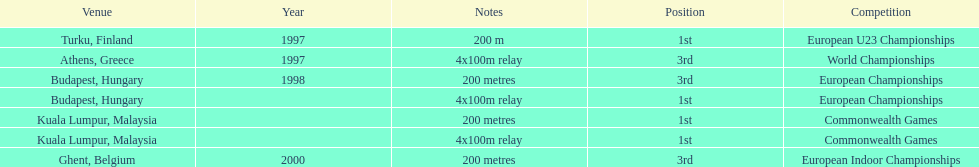What was the only event won in belgium? European Indoor Championships. 